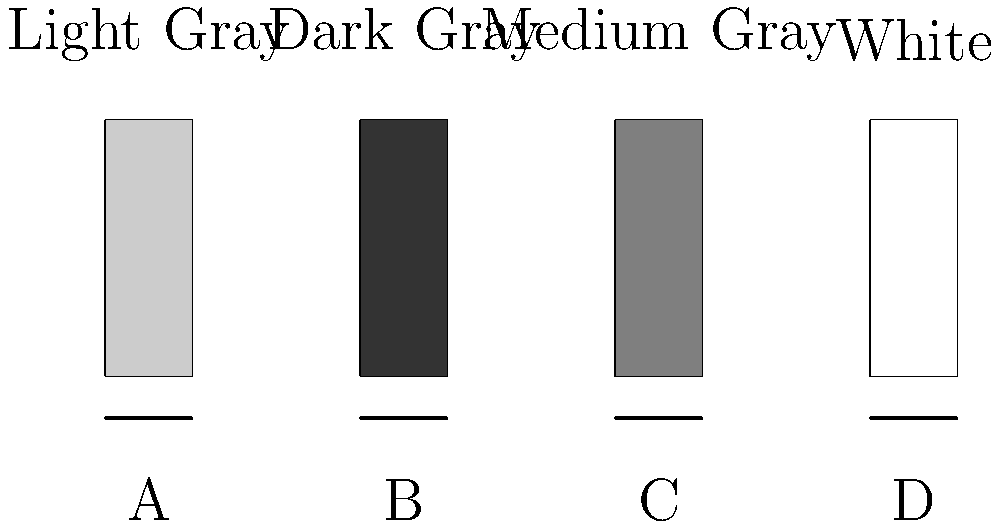In the diagram above, four vials containing different types of contrast media are shown. Based on their appearance, which vial most likely contains iodinated contrast media? To identify the vial containing iodinated contrast media, let's consider the properties of different contrast agents:

1. Iodinated contrast media: Typically appears white or very light gray on radiographs due to its high atomic number and density.
2. Barium contrast media: Usually appears white or light gray, similar to iodinated contrast.
3. Air contrast: Appears dark or black on radiographs.
4. Gadolinium-based contrast agents: Generally not visible on conventional radiographs, but would appear gray if concentrated.

Analyzing the vials in the diagram:

A. Light gray: Could be diluted iodinated or barium contrast.
B. Dark gray: Likely represents air contrast.
C. Medium gray: Might represent a gadolinium-based agent or diluted contrast.
D. White: Most likely represents undiluted iodinated or barium contrast.

Given that the question specifically asks about iodinated contrast media, and considering its characteristic appearance on radiographs, the vial that most likely contains iodinated contrast media is vial D, which appears white in the diagram.
Answer: D 